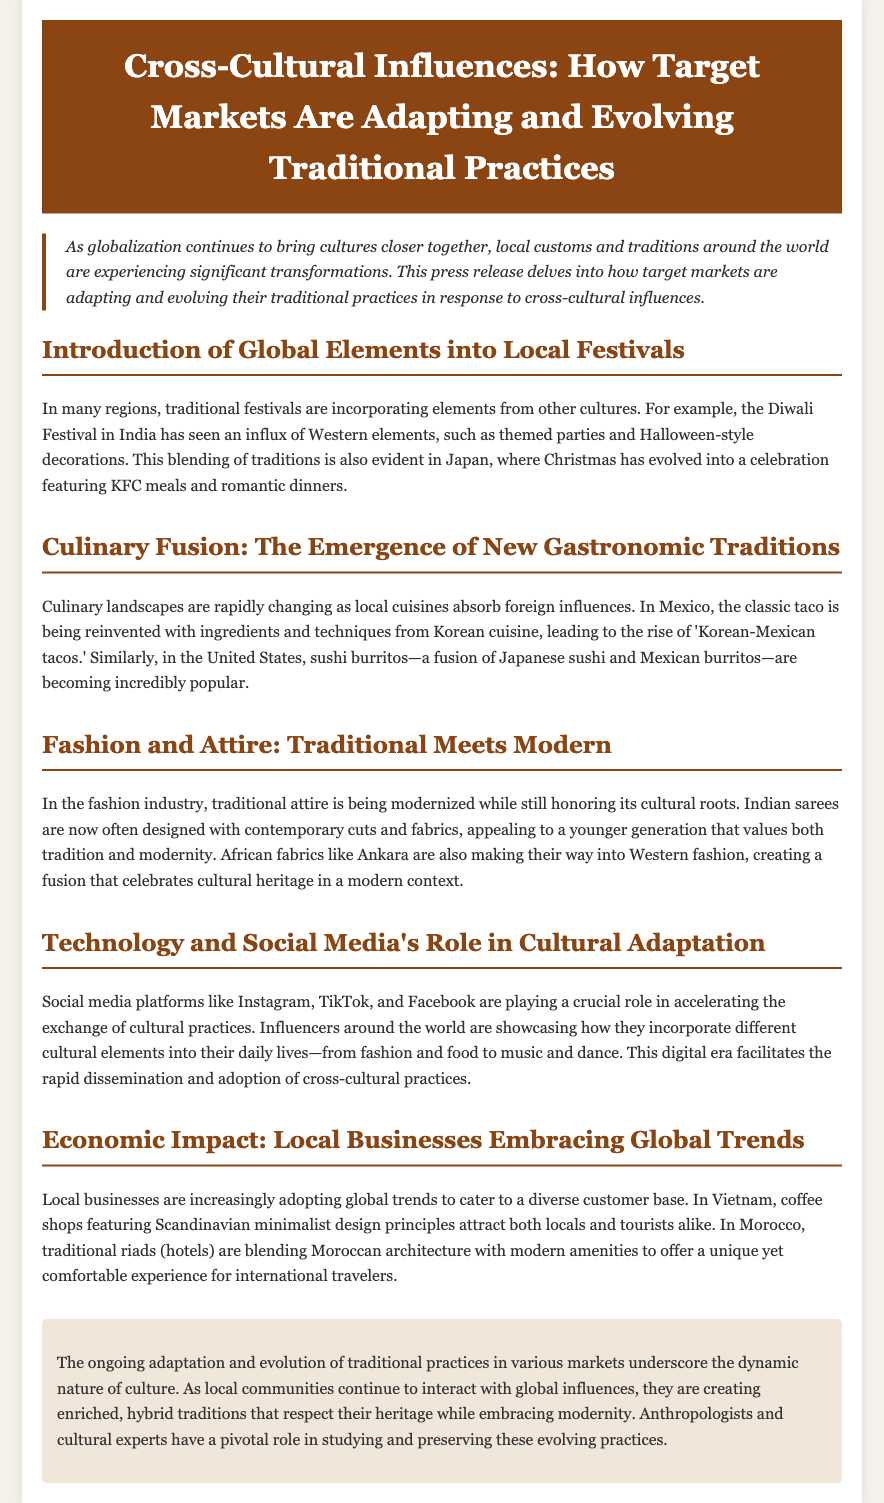What is the primary focus of the press release? The press release discusses how local customs and traditions are transforming due to globalization and cross-cultural influences.
Answer: Cross-cultural influences What example is given for a festival that incorporates global elements? The document mentions how the Diwali Festival in India has included Western elements.
Answer: Diwali Festival What new culinary trend is highlighted in Mexico? The press release refers to the rise of 'Korean-Mexican tacos' as a fusion of local and foreign cuisines.
Answer: Korean-Mexican tacos How does social media influence cultural practices according to the document? The press release explains that social media accelerates the exchange and adoption of cultural practices globally.
Answer: Accelerating exchange Which traditional attire is modernized in the fashion industry? The document discusses Indian sarees being designed with contemporary cuts and fabrics.
Answer: Indian sarees What economic change is noted in Vietnam's coffee shops? The press release highlights that coffee shops are adopting Scandinavian minimalist design principles.
Answer: Scandinavian minimalist design How are local businesses responding to global trends? Local businesses are increasingly embracing global trends to cater to diverse customers.
Answer: Embracing global trends What is the nature of culture as described in the conclusion? The conclusion states that the ongoing adaptation shows the dynamic nature of culture.
Answer: Dynamic nature What role do anthropologists have in the evolving practices? The document claims that anthropologists have a pivotal role in studying and preserving evolving practices.
Answer: Pivotal role 